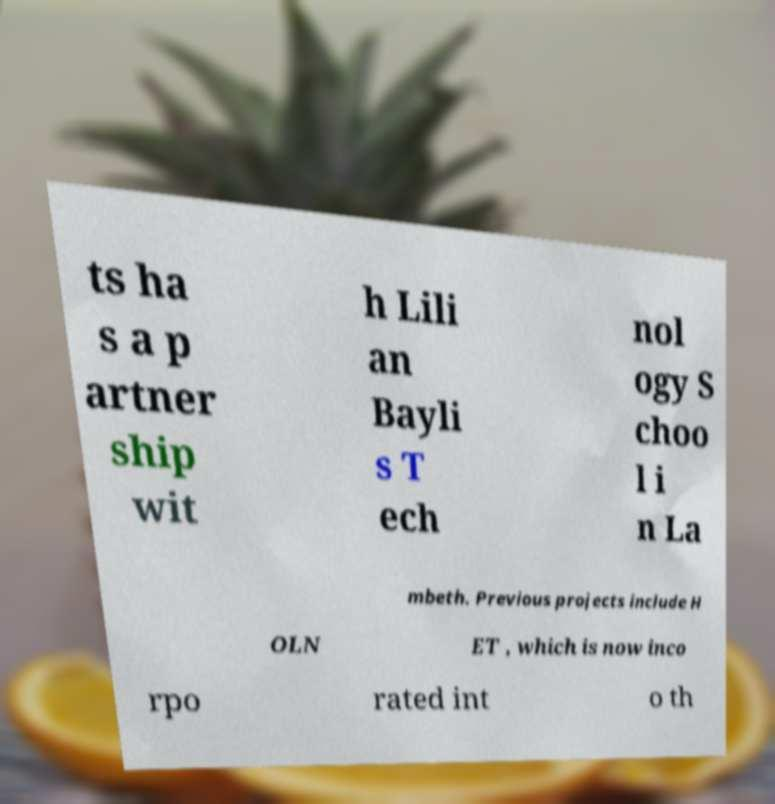Could you extract and type out the text from this image? ts ha s a p artner ship wit h Lili an Bayli s T ech nol ogy S choo l i n La mbeth. Previous projects include H OLN ET , which is now inco rpo rated int o th 